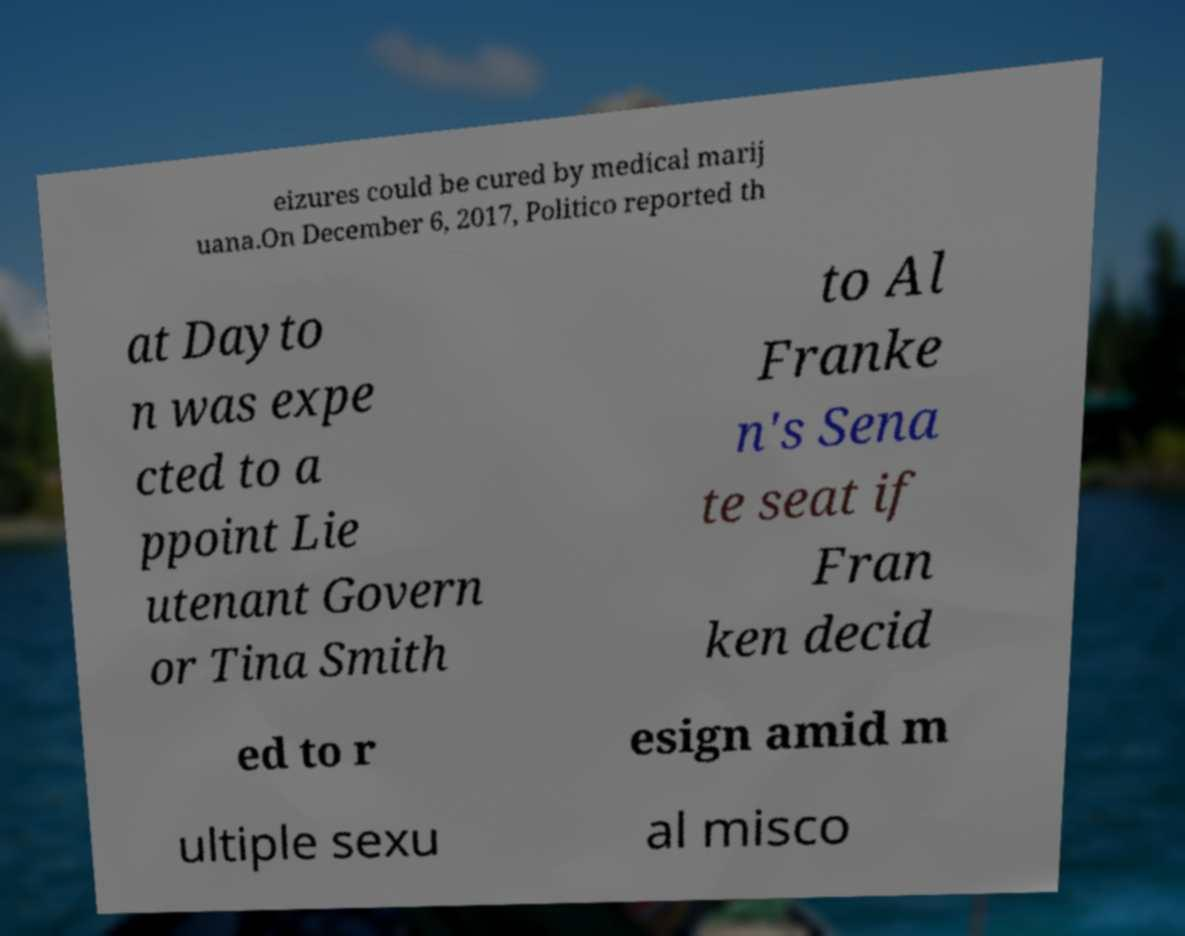Please identify and transcribe the text found in this image. eizures could be cured by medical marij uana.On December 6, 2017, Politico reported th at Dayto n was expe cted to a ppoint Lie utenant Govern or Tina Smith to Al Franke n's Sena te seat if Fran ken decid ed to r esign amid m ultiple sexu al misco 